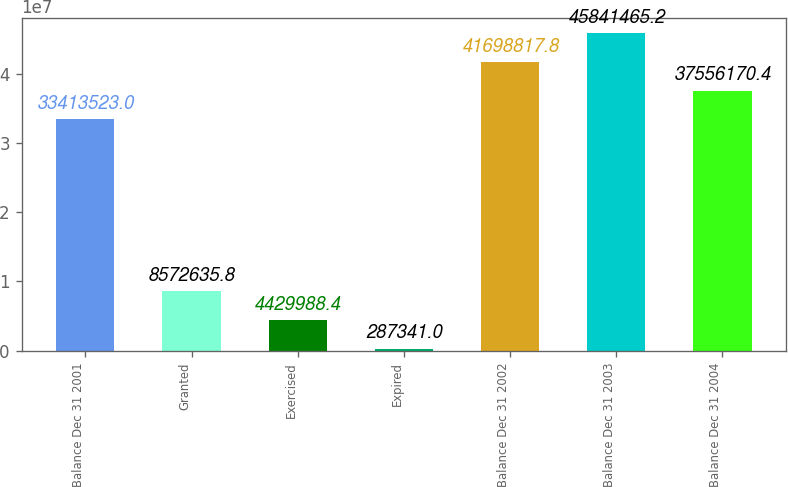<chart> <loc_0><loc_0><loc_500><loc_500><bar_chart><fcel>Balance Dec 31 2001<fcel>Granted<fcel>Exercised<fcel>Expired<fcel>Balance Dec 31 2002<fcel>Balance Dec 31 2003<fcel>Balance Dec 31 2004<nl><fcel>3.34135e+07<fcel>8.57264e+06<fcel>4.42999e+06<fcel>287341<fcel>4.16988e+07<fcel>4.58415e+07<fcel>3.75562e+07<nl></chart> 